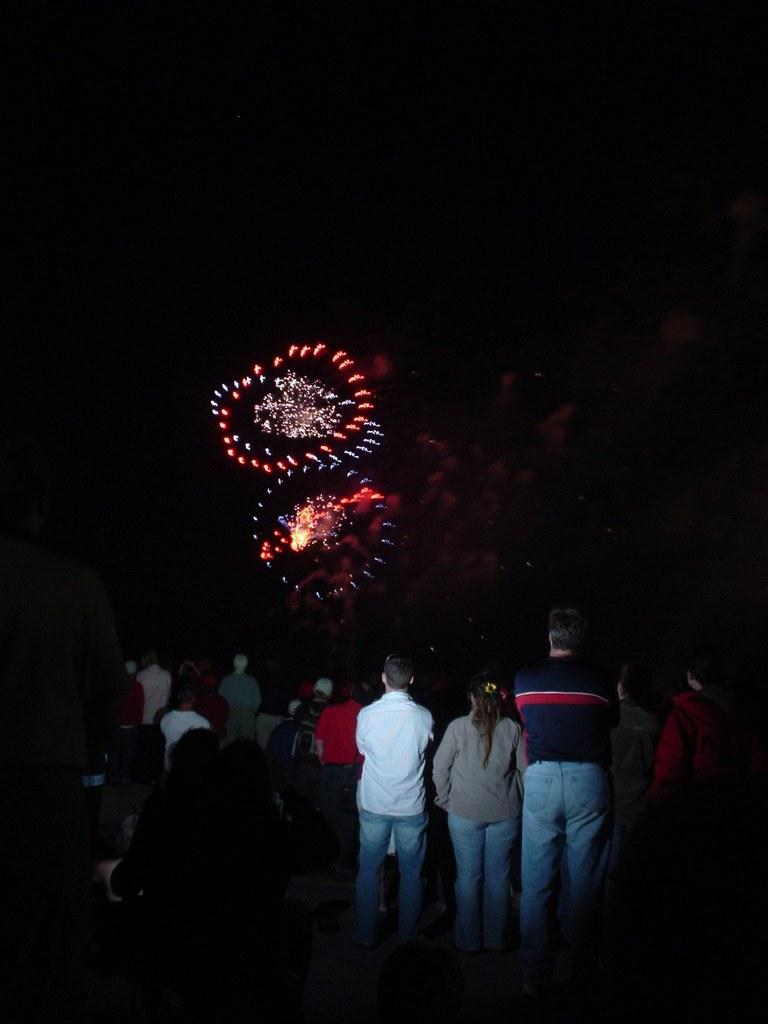Who or what can be seen in the image? There are people in the image. What is the color of the background in the image? The background of the image is dark. What additional detail can be observed in the background? Sparkles are visible in the background of the image. What type of twig is being used as an afterthought in the image? There is no twig present in the image, nor is there any indication of an afterthought. 